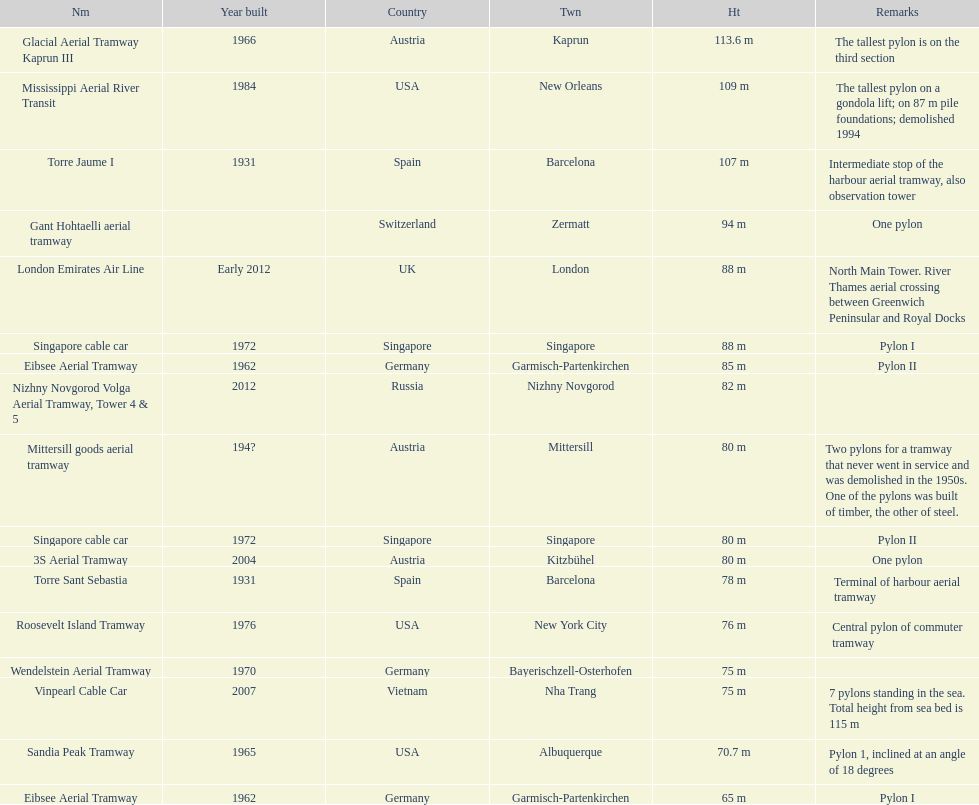Which pylon has the most remarks about it? Mittersill goods aerial tramway. 